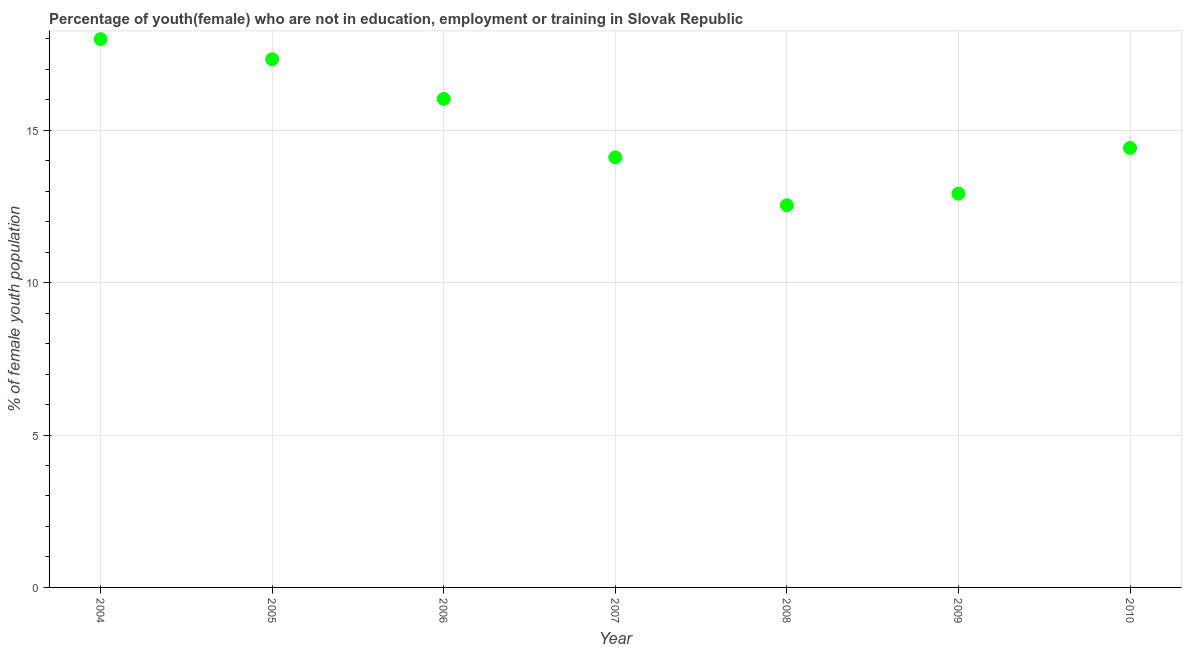What is the unemployed female youth population in 2009?
Offer a very short reply. 12.92. Across all years, what is the maximum unemployed female youth population?
Provide a succinct answer. 17.99. Across all years, what is the minimum unemployed female youth population?
Provide a succinct answer. 12.54. In which year was the unemployed female youth population minimum?
Offer a terse response. 2008. What is the sum of the unemployed female youth population?
Keep it short and to the point. 105.34. What is the difference between the unemployed female youth population in 2004 and 2008?
Ensure brevity in your answer.  5.45. What is the average unemployed female youth population per year?
Ensure brevity in your answer.  15.05. What is the median unemployed female youth population?
Your answer should be very brief. 14.42. What is the ratio of the unemployed female youth population in 2009 to that in 2010?
Keep it short and to the point. 0.9. Is the difference between the unemployed female youth population in 2006 and 2009 greater than the difference between any two years?
Keep it short and to the point. No. What is the difference between the highest and the second highest unemployed female youth population?
Your answer should be very brief. 0.66. Is the sum of the unemployed female youth population in 2007 and 2008 greater than the maximum unemployed female youth population across all years?
Give a very brief answer. Yes. What is the difference between the highest and the lowest unemployed female youth population?
Make the answer very short. 5.45. Does the unemployed female youth population monotonically increase over the years?
Keep it short and to the point. No. Are the values on the major ticks of Y-axis written in scientific E-notation?
Your answer should be compact. No. Does the graph contain grids?
Your answer should be compact. Yes. What is the title of the graph?
Your answer should be very brief. Percentage of youth(female) who are not in education, employment or training in Slovak Republic. What is the label or title of the Y-axis?
Keep it short and to the point. % of female youth population. What is the % of female youth population in 2004?
Ensure brevity in your answer.  17.99. What is the % of female youth population in 2005?
Give a very brief answer. 17.33. What is the % of female youth population in 2006?
Ensure brevity in your answer.  16.03. What is the % of female youth population in 2007?
Your response must be concise. 14.11. What is the % of female youth population in 2008?
Offer a very short reply. 12.54. What is the % of female youth population in 2009?
Give a very brief answer. 12.92. What is the % of female youth population in 2010?
Your answer should be compact. 14.42. What is the difference between the % of female youth population in 2004 and 2005?
Give a very brief answer. 0.66. What is the difference between the % of female youth population in 2004 and 2006?
Offer a terse response. 1.96. What is the difference between the % of female youth population in 2004 and 2007?
Your answer should be very brief. 3.88. What is the difference between the % of female youth population in 2004 and 2008?
Provide a short and direct response. 5.45. What is the difference between the % of female youth population in 2004 and 2009?
Your response must be concise. 5.07. What is the difference between the % of female youth population in 2004 and 2010?
Provide a succinct answer. 3.57. What is the difference between the % of female youth population in 2005 and 2006?
Offer a terse response. 1.3. What is the difference between the % of female youth population in 2005 and 2007?
Give a very brief answer. 3.22. What is the difference between the % of female youth population in 2005 and 2008?
Offer a very short reply. 4.79. What is the difference between the % of female youth population in 2005 and 2009?
Your answer should be very brief. 4.41. What is the difference between the % of female youth population in 2005 and 2010?
Offer a terse response. 2.91. What is the difference between the % of female youth population in 2006 and 2007?
Your answer should be compact. 1.92. What is the difference between the % of female youth population in 2006 and 2008?
Provide a short and direct response. 3.49. What is the difference between the % of female youth population in 2006 and 2009?
Make the answer very short. 3.11. What is the difference between the % of female youth population in 2006 and 2010?
Your answer should be very brief. 1.61. What is the difference between the % of female youth population in 2007 and 2008?
Your response must be concise. 1.57. What is the difference between the % of female youth population in 2007 and 2009?
Your answer should be compact. 1.19. What is the difference between the % of female youth population in 2007 and 2010?
Offer a terse response. -0.31. What is the difference between the % of female youth population in 2008 and 2009?
Keep it short and to the point. -0.38. What is the difference between the % of female youth population in 2008 and 2010?
Make the answer very short. -1.88. What is the ratio of the % of female youth population in 2004 to that in 2005?
Make the answer very short. 1.04. What is the ratio of the % of female youth population in 2004 to that in 2006?
Provide a short and direct response. 1.12. What is the ratio of the % of female youth population in 2004 to that in 2007?
Give a very brief answer. 1.27. What is the ratio of the % of female youth population in 2004 to that in 2008?
Provide a succinct answer. 1.44. What is the ratio of the % of female youth population in 2004 to that in 2009?
Ensure brevity in your answer.  1.39. What is the ratio of the % of female youth population in 2004 to that in 2010?
Offer a terse response. 1.25. What is the ratio of the % of female youth population in 2005 to that in 2006?
Ensure brevity in your answer.  1.08. What is the ratio of the % of female youth population in 2005 to that in 2007?
Your answer should be compact. 1.23. What is the ratio of the % of female youth population in 2005 to that in 2008?
Make the answer very short. 1.38. What is the ratio of the % of female youth population in 2005 to that in 2009?
Offer a very short reply. 1.34. What is the ratio of the % of female youth population in 2005 to that in 2010?
Provide a short and direct response. 1.2. What is the ratio of the % of female youth population in 2006 to that in 2007?
Your answer should be very brief. 1.14. What is the ratio of the % of female youth population in 2006 to that in 2008?
Your response must be concise. 1.28. What is the ratio of the % of female youth population in 2006 to that in 2009?
Offer a very short reply. 1.24. What is the ratio of the % of female youth population in 2006 to that in 2010?
Your answer should be very brief. 1.11. What is the ratio of the % of female youth population in 2007 to that in 2008?
Your response must be concise. 1.12. What is the ratio of the % of female youth population in 2007 to that in 2009?
Offer a very short reply. 1.09. What is the ratio of the % of female youth population in 2008 to that in 2009?
Your answer should be very brief. 0.97. What is the ratio of the % of female youth population in 2008 to that in 2010?
Your answer should be very brief. 0.87. What is the ratio of the % of female youth population in 2009 to that in 2010?
Give a very brief answer. 0.9. 